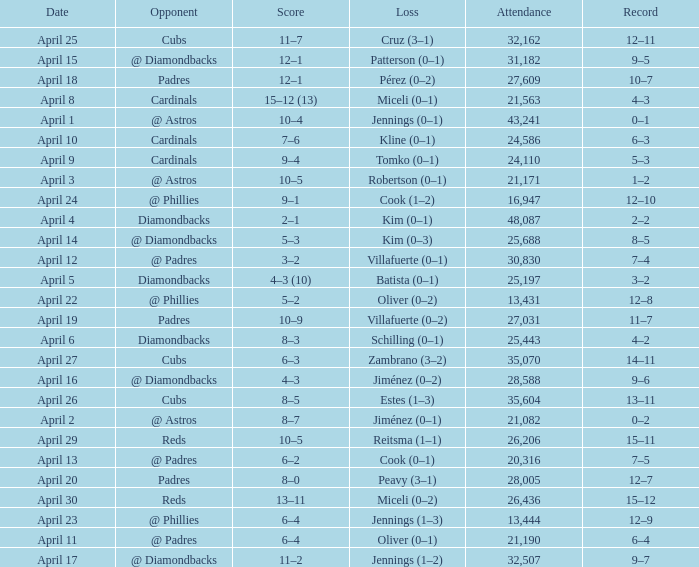What is the team's record on april 23? 12–9. 